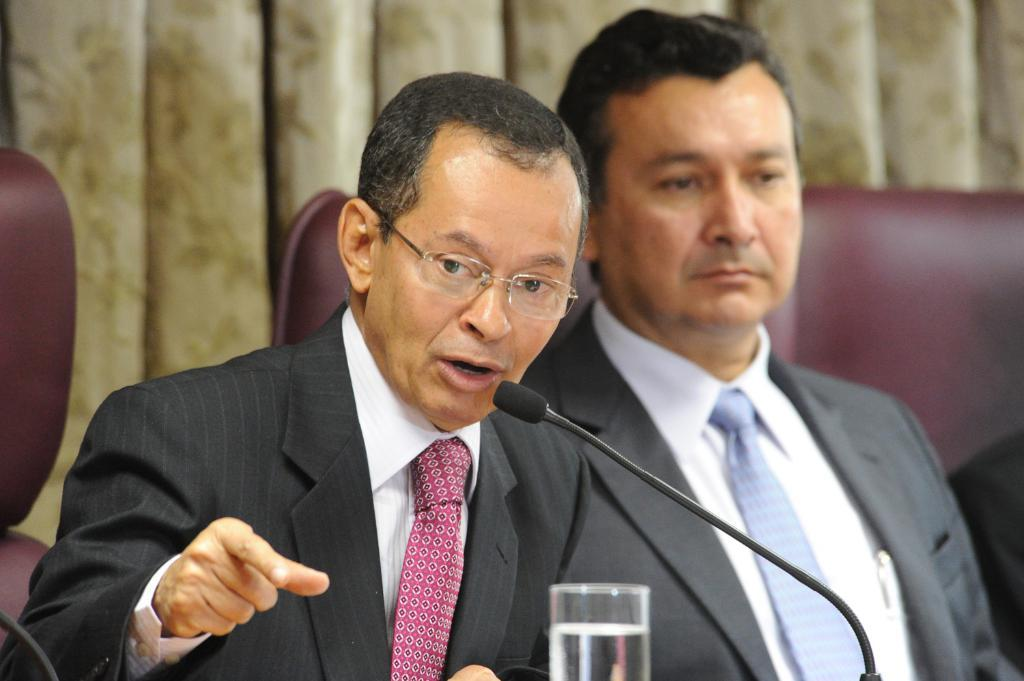What are the people in the image doing? The people in the image are sitting on chairs. What is in front of the people? There is a meal in front of the people. What can be seen in a glass on the table? There is water in a glass on the table. What can be seen in the background of the image? There are curtains visible in the background. What type of wire is being used to play a musical horn in the image? There is no wire or musical horn present in the image. 